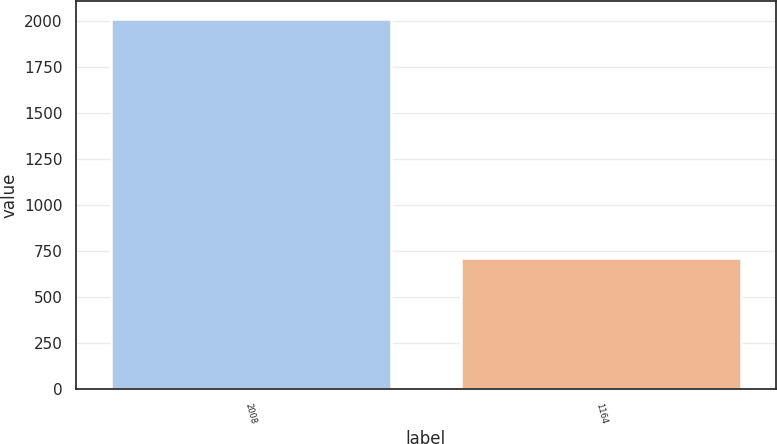Convert chart to OTSL. <chart><loc_0><loc_0><loc_500><loc_500><bar_chart><fcel>2008<fcel>1164<nl><fcel>2010<fcel>715<nl></chart> 